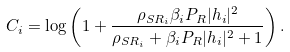Convert formula to latex. <formula><loc_0><loc_0><loc_500><loc_500>C _ { i } = \log \left ( 1 + \frac { \rho _ { S R _ { i } } \beta _ { i } P _ { R } | h _ { i } | ^ { 2 } } { \rho _ { S R _ { i } } + \beta _ { i } P _ { R } | h _ { i } | ^ { 2 } + 1 } \right ) .</formula> 